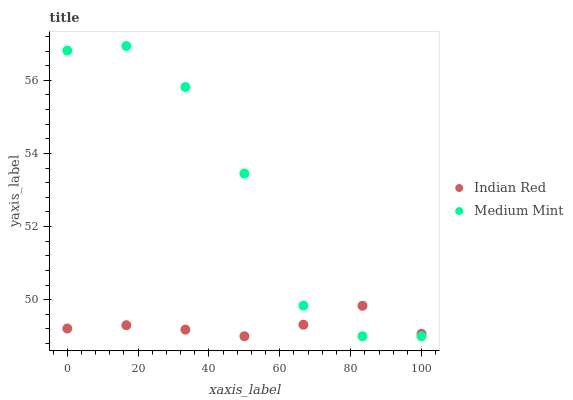Does Indian Red have the minimum area under the curve?
Answer yes or no. Yes. Does Medium Mint have the maximum area under the curve?
Answer yes or no. Yes. Does Indian Red have the maximum area under the curve?
Answer yes or no. No. Is Indian Red the smoothest?
Answer yes or no. Yes. Is Medium Mint the roughest?
Answer yes or no. Yes. Is Indian Red the roughest?
Answer yes or no. No. Does Medium Mint have the lowest value?
Answer yes or no. Yes. Does Medium Mint have the highest value?
Answer yes or no. Yes. Does Indian Red have the highest value?
Answer yes or no. No. Does Medium Mint intersect Indian Red?
Answer yes or no. Yes. Is Medium Mint less than Indian Red?
Answer yes or no. No. Is Medium Mint greater than Indian Red?
Answer yes or no. No. 